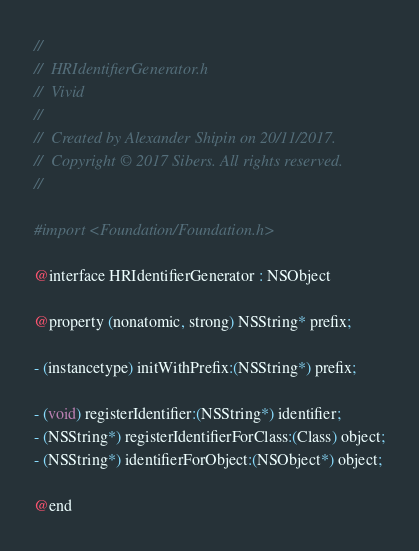Convert code to text. <code><loc_0><loc_0><loc_500><loc_500><_C_>//
//  HRIdentifierGenerator.h
//  Vivid
//
//  Created by Alexander Shipin on 20/11/2017.
//  Copyright © 2017 Sibers. All rights reserved.
//

#import <Foundation/Foundation.h>

@interface HRIdentifierGenerator : NSObject

@property (nonatomic, strong) NSString* prefix;

- (instancetype) initWithPrefix:(NSString*) prefix;

- (void) registerIdentifier:(NSString*) identifier;
- (NSString*) registerIdentifierForClass:(Class) object;
- (NSString*) identifierForObject:(NSObject*) object;

@end
</code> 